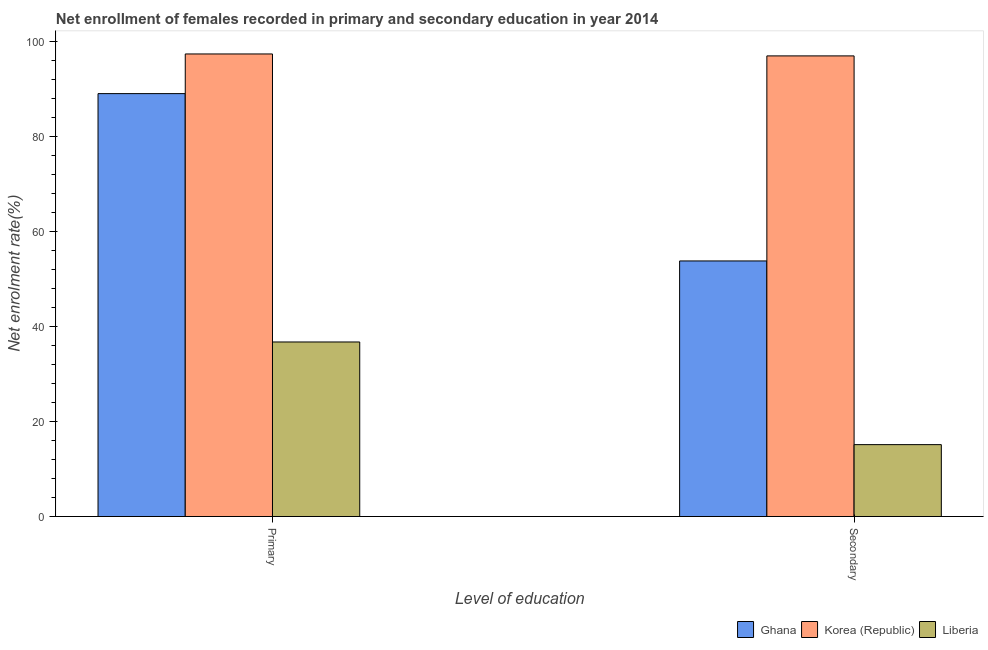How many groups of bars are there?
Provide a short and direct response. 2. Are the number of bars per tick equal to the number of legend labels?
Your answer should be compact. Yes. Are the number of bars on each tick of the X-axis equal?
Provide a short and direct response. Yes. How many bars are there on the 2nd tick from the right?
Offer a terse response. 3. What is the label of the 1st group of bars from the left?
Provide a short and direct response. Primary. What is the enrollment rate in secondary education in Ghana?
Your answer should be compact. 53.8. Across all countries, what is the maximum enrollment rate in primary education?
Provide a succinct answer. 97.38. Across all countries, what is the minimum enrollment rate in primary education?
Ensure brevity in your answer.  36.74. In which country was the enrollment rate in secondary education maximum?
Keep it short and to the point. Korea (Republic). In which country was the enrollment rate in secondary education minimum?
Ensure brevity in your answer.  Liberia. What is the total enrollment rate in primary education in the graph?
Ensure brevity in your answer.  223.14. What is the difference between the enrollment rate in primary education in Ghana and that in Korea (Republic)?
Offer a very short reply. -8.35. What is the difference between the enrollment rate in secondary education in Liberia and the enrollment rate in primary education in Korea (Republic)?
Make the answer very short. -82.24. What is the average enrollment rate in primary education per country?
Make the answer very short. 74.38. What is the difference between the enrollment rate in primary education and enrollment rate in secondary education in Liberia?
Your response must be concise. 21.61. In how many countries, is the enrollment rate in primary education greater than 4 %?
Your answer should be very brief. 3. What is the ratio of the enrollment rate in secondary education in Ghana to that in Liberia?
Your answer should be compact. 3.56. Is the enrollment rate in primary education in Korea (Republic) less than that in Liberia?
Give a very brief answer. No. What does the 1st bar from the right in Secondary represents?
Your answer should be very brief. Liberia. How many bars are there?
Offer a terse response. 6. How many countries are there in the graph?
Your answer should be compact. 3. Does the graph contain any zero values?
Provide a succinct answer. No. Does the graph contain grids?
Offer a terse response. No. Where does the legend appear in the graph?
Offer a very short reply. Bottom right. What is the title of the graph?
Provide a succinct answer. Net enrollment of females recorded in primary and secondary education in year 2014. What is the label or title of the X-axis?
Make the answer very short. Level of education. What is the label or title of the Y-axis?
Keep it short and to the point. Net enrolment rate(%). What is the Net enrolment rate(%) in Ghana in Primary?
Provide a succinct answer. 89.03. What is the Net enrolment rate(%) of Korea (Republic) in Primary?
Provide a succinct answer. 97.38. What is the Net enrolment rate(%) in Liberia in Primary?
Offer a terse response. 36.74. What is the Net enrolment rate(%) in Ghana in Secondary?
Make the answer very short. 53.8. What is the Net enrolment rate(%) in Korea (Republic) in Secondary?
Your answer should be very brief. 96.96. What is the Net enrolment rate(%) in Liberia in Secondary?
Provide a succinct answer. 15.13. Across all Level of education, what is the maximum Net enrolment rate(%) in Ghana?
Make the answer very short. 89.03. Across all Level of education, what is the maximum Net enrolment rate(%) in Korea (Republic)?
Offer a very short reply. 97.38. Across all Level of education, what is the maximum Net enrolment rate(%) of Liberia?
Ensure brevity in your answer.  36.74. Across all Level of education, what is the minimum Net enrolment rate(%) of Ghana?
Your answer should be compact. 53.8. Across all Level of education, what is the minimum Net enrolment rate(%) of Korea (Republic)?
Offer a terse response. 96.96. Across all Level of education, what is the minimum Net enrolment rate(%) of Liberia?
Provide a short and direct response. 15.13. What is the total Net enrolment rate(%) in Ghana in the graph?
Your answer should be very brief. 142.83. What is the total Net enrolment rate(%) in Korea (Republic) in the graph?
Make the answer very short. 194.34. What is the total Net enrolment rate(%) of Liberia in the graph?
Make the answer very short. 51.88. What is the difference between the Net enrolment rate(%) of Ghana in Primary and that in Secondary?
Provide a succinct answer. 35.22. What is the difference between the Net enrolment rate(%) in Korea (Republic) in Primary and that in Secondary?
Give a very brief answer. 0.41. What is the difference between the Net enrolment rate(%) of Liberia in Primary and that in Secondary?
Your response must be concise. 21.61. What is the difference between the Net enrolment rate(%) of Ghana in Primary and the Net enrolment rate(%) of Korea (Republic) in Secondary?
Give a very brief answer. -7.94. What is the difference between the Net enrolment rate(%) of Ghana in Primary and the Net enrolment rate(%) of Liberia in Secondary?
Keep it short and to the point. 73.89. What is the difference between the Net enrolment rate(%) of Korea (Republic) in Primary and the Net enrolment rate(%) of Liberia in Secondary?
Give a very brief answer. 82.24. What is the average Net enrolment rate(%) in Ghana per Level of education?
Keep it short and to the point. 71.41. What is the average Net enrolment rate(%) in Korea (Republic) per Level of education?
Make the answer very short. 97.17. What is the average Net enrolment rate(%) in Liberia per Level of education?
Provide a short and direct response. 25.94. What is the difference between the Net enrolment rate(%) of Ghana and Net enrolment rate(%) of Korea (Republic) in Primary?
Offer a terse response. -8.35. What is the difference between the Net enrolment rate(%) of Ghana and Net enrolment rate(%) of Liberia in Primary?
Give a very brief answer. 52.28. What is the difference between the Net enrolment rate(%) of Korea (Republic) and Net enrolment rate(%) of Liberia in Primary?
Give a very brief answer. 60.63. What is the difference between the Net enrolment rate(%) of Ghana and Net enrolment rate(%) of Korea (Republic) in Secondary?
Ensure brevity in your answer.  -43.16. What is the difference between the Net enrolment rate(%) of Ghana and Net enrolment rate(%) of Liberia in Secondary?
Keep it short and to the point. 38.67. What is the difference between the Net enrolment rate(%) in Korea (Republic) and Net enrolment rate(%) in Liberia in Secondary?
Give a very brief answer. 81.83. What is the ratio of the Net enrolment rate(%) of Ghana in Primary to that in Secondary?
Make the answer very short. 1.65. What is the ratio of the Net enrolment rate(%) of Liberia in Primary to that in Secondary?
Your answer should be very brief. 2.43. What is the difference between the highest and the second highest Net enrolment rate(%) in Ghana?
Your answer should be compact. 35.22. What is the difference between the highest and the second highest Net enrolment rate(%) in Korea (Republic)?
Your response must be concise. 0.41. What is the difference between the highest and the second highest Net enrolment rate(%) of Liberia?
Your answer should be compact. 21.61. What is the difference between the highest and the lowest Net enrolment rate(%) of Ghana?
Your answer should be compact. 35.22. What is the difference between the highest and the lowest Net enrolment rate(%) in Korea (Republic)?
Your answer should be compact. 0.41. What is the difference between the highest and the lowest Net enrolment rate(%) of Liberia?
Your answer should be compact. 21.61. 